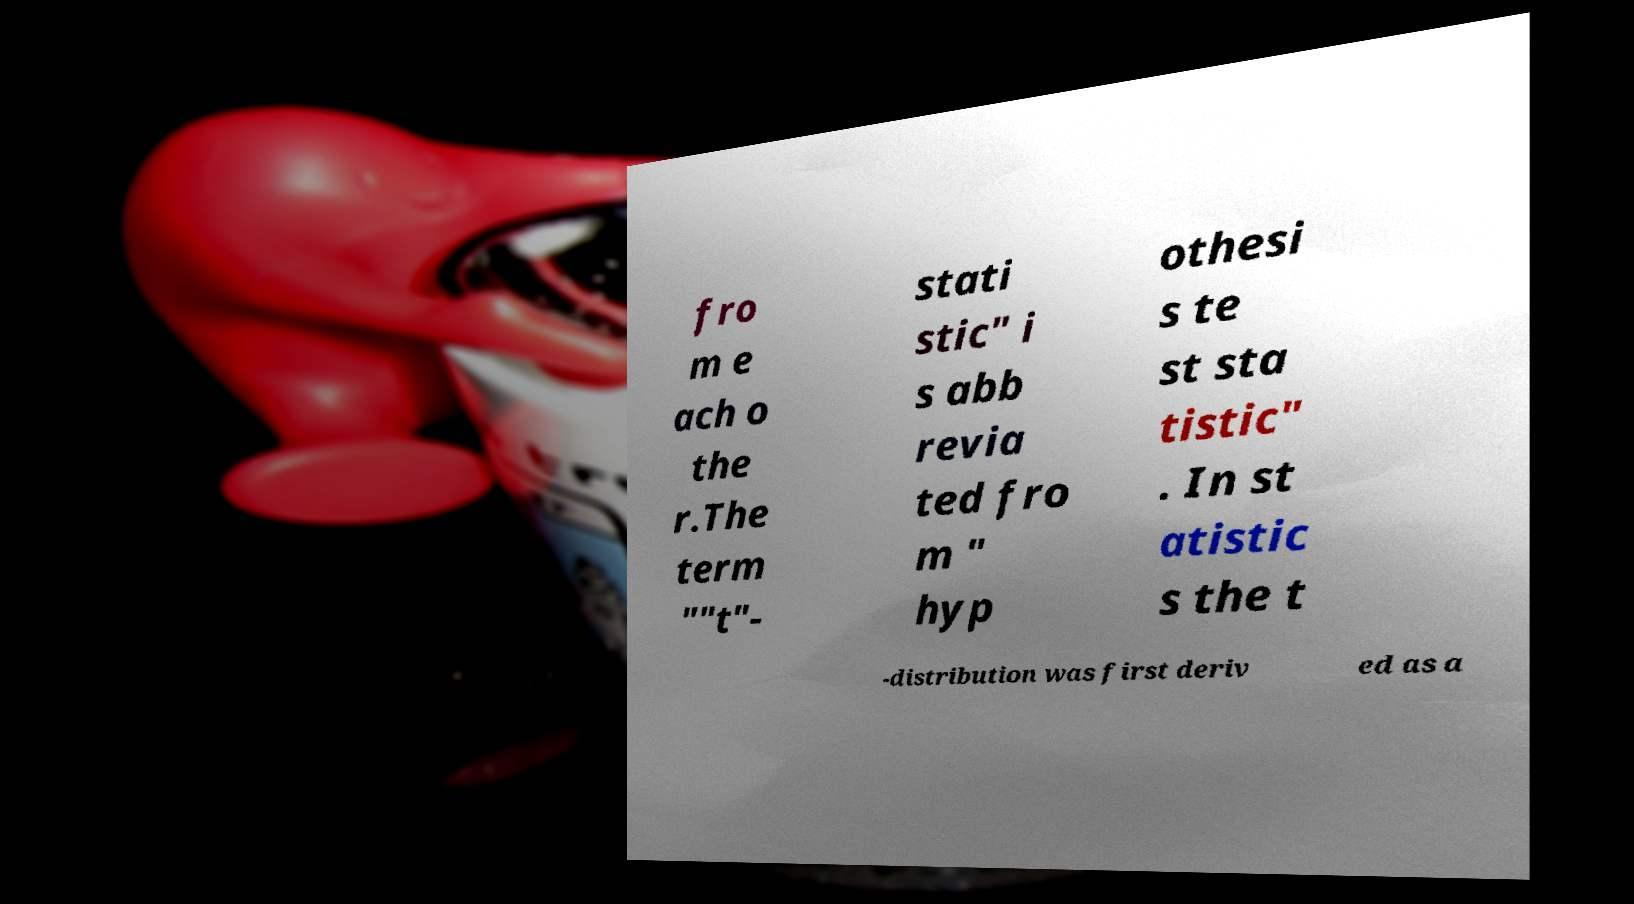For documentation purposes, I need the text within this image transcribed. Could you provide that? fro m e ach o the r.The term ""t"- stati stic" i s abb revia ted fro m " hyp othesi s te st sta tistic" . In st atistic s the t -distribution was first deriv ed as a 